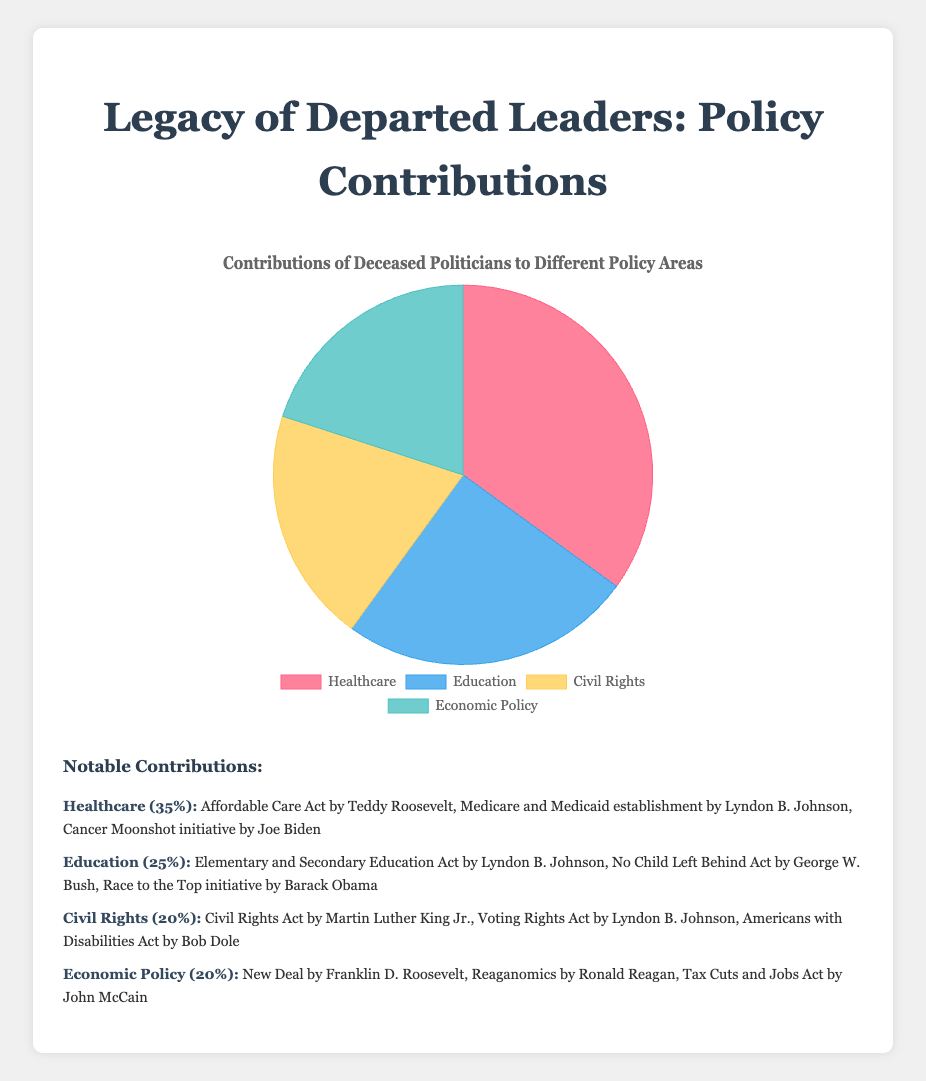What percentage of contributions is attributed to Healthcare? The figure shows that Healthcare accounts for 35% of the contributions by deceased politicians.
Answer: 35% What is the combined percentage of contributions to Civil Rights and Economic Policy? The figure shows that Civil Rights has a 20% contribution and Economic Policy also has a 20% contribution. Combined, these contributions are 20% + 20% = 40%.
Answer: 40% Which policy area has the least contribution and by how much? The figure indicates that Civil Rights and Economic Policy both have the least contributions at 20%. Another policy area that has a higher contribution is Education at 25%. The difference between Education (25%) and Civil Rights or Economic Policy (20%) is 5%.
Answer: Civil Rights and Economic Policy, by 5% What is the ratio of contributions between Healthcare and Education? The contributions are 35% for Healthcare and 25% for Education. To find the ratio, we divide the contributions: 35% / 25% = 7/5.
Answer: 7:5 How do the contributions to Civil Rights compare with those to Healthcare? Civil Rights contributions are 20%, while Healthcare contributions are 35%. Thus, contributions to Healthcare are 35% - 20% = 15% greater than those to Civil Rights.
Answer: Contributions to Healthcare are 15% greater than contributions to Civil Rights Which notable policy was enacted by Franklin D. Roosevelt, and in which sector does it fall? The notable policy enacted by Franklin D. Roosevelt is the New Deal, and it falls under Economic Policy.
Answer: New Deal, Economic Policy If contributions to Economic Policy increased by 10%, what would be the new percentage, and would it surpass any sector? The current contribution to Economic Policy is 20%. Increasing it by 10% results in a new contribution of 20% + 10% = 30%. This new percentage would surpass the Education sector, which contributes 25%.
Answer: 30%, surpasses Education Among the sectors, which one has the second-highest contribution, and which notable acts are part of it? The second-highest contribution is from Education, with 25%. Notable acts in Education include the Elementary and Secondary Education Act by Lyndon B. Johnson, No Child Left Behind Act by George W. Bush, and Race to the Top initiative by Barack Obama.
Answer: Education, includes Elementary and Secondary Education Act, No Child Left Behind Act, and Race to the Top initiative What is the total percentage of contributions by deceased politicians to Education and Civil Rights combined? The contributions are 25% for Education and 20% for Civil Rights. Combined, these contributions are 25% + 20% = 45%.
Answer: 45% 